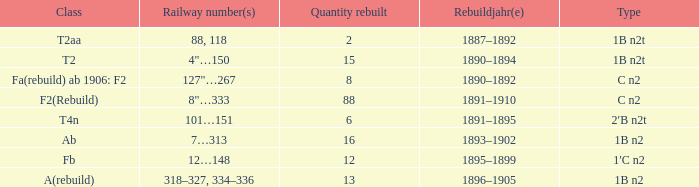For a type 1b n2t with railway numbers 88 and 118, what is the cumulative quantity of rebuilding? 1.0. 